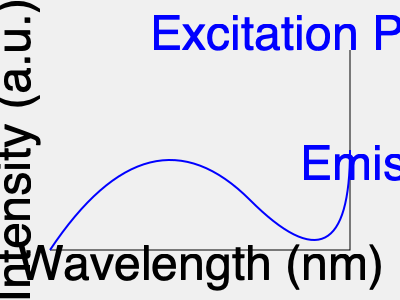In the fluorescence spectrum shown above for a water sample, what does the difference between the wavelengths of the excitation and emission peaks represent, and how is this information useful in water quality assessment? To answer this question, we need to understand the principles of fluorescence spectroscopy and its application in water quality assessment:

1. Fluorescence spectroscopy basics:
   - Molecules absorb light at a specific wavelength (excitation)
   - They then emit light at a longer wavelength (emission)

2. Interpreting the graph:
   - The x-axis represents wavelength (nm)
   - The y-axis represents intensity (arbitrary units)
   - The blue curve shows both excitation and emission peaks

3. Stokes shift:
   - The difference between excitation and emission wavelengths is called the Stokes shift
   - Mathematically: $\text{Stokes shift} = \lambda_{\text{emission}} - \lambda_{\text{excitation}}$

4. Significance in water quality assessment:
   - Different compounds have characteristic Stokes shifts
   - This allows for identification of specific fluorophores in water samples
   - Examples: dissolved organic matter, pollutants, algal pigments

5. Applications:
   - Monitoring organic pollution
   - Detecting harmful algal blooms
   - Tracing contamination sources
   - Assessing treatment efficacy in water purification systems

The Stokes shift provides a unique "fingerprint" for various compounds, enabling rapid and sensitive analysis of water quality parameters without extensive sample preparation.
Answer: Stokes shift; identifies specific fluorophores for water quality analysis 